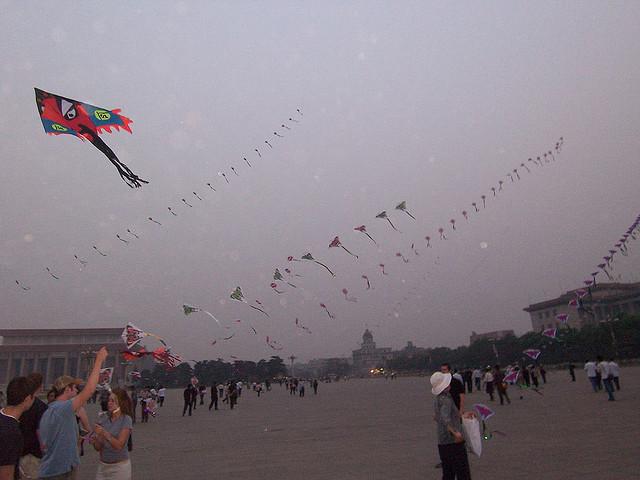What are the people wearing on their heads?
Quick response, please. Hats. Are there any mountains around?
Keep it brief. No. Could this be a military exercise?
Answer briefly. No. Is it sunny in the picture?
Quick response, please. No. What is flying in the air?
Quick response, please. Kites. What color is the kite most visible on the left?
Keep it brief. Red and blue. Is his shirt colorful?
Answer briefly. No. Is this an Olympic sport?
Short answer required. No. Are the people upside down?
Short answer required. No. What type of sport is this?
Quick response, please. Kite flying. 